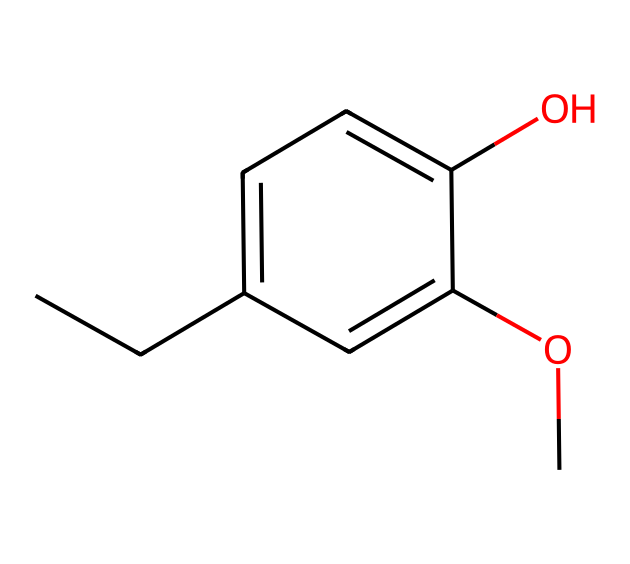What is the primary functional group present in this chemical? The chemical structure contains a hydroxyl group (-OH) attached to a carbon atom in the aromatic ring, indicating that it is a phenol.
Answer: hydroxyl group How many carbon atoms are in this chemical structure? By counting the number of carbon atoms in the SMILES representation, there are 10 carbon atoms in total.
Answer: 10 What type of aromatic compound is this molecule classified as? The presence of a hydroxyl (-OH) group on the benzene ring classifies this compound as a phenolic compound.
Answer: phenolic What is the total number of oxygen atoms in this molecule? The chemical has two oxygen atoms, one from the hydroxyl group and one from the methoxy group (-OCH3).
Answer: 2 What is the significance of the methoxy group in the structure? The methoxy group contributes to the overall hydrophobic character of the compound and can influence its solubility and aroma, important for fragrance in wedding flowers.
Answer: hydrophobic character What is the basic property that affects the scent of this compound? The presence of the -OCH3 (methoxy group) and -OH (hydroxyl group) contributes to the molecule's stability and volatility, which are crucial for its aromatic properties.
Answer: volatility Which part of the molecule indicates its potential for antioxidant properties? The presence of the phenolic hydroxyl group (-OH) is known to contribute to antioxidant activity, as it can donate hydrogen atoms to free radicals.
Answer: -OH group 